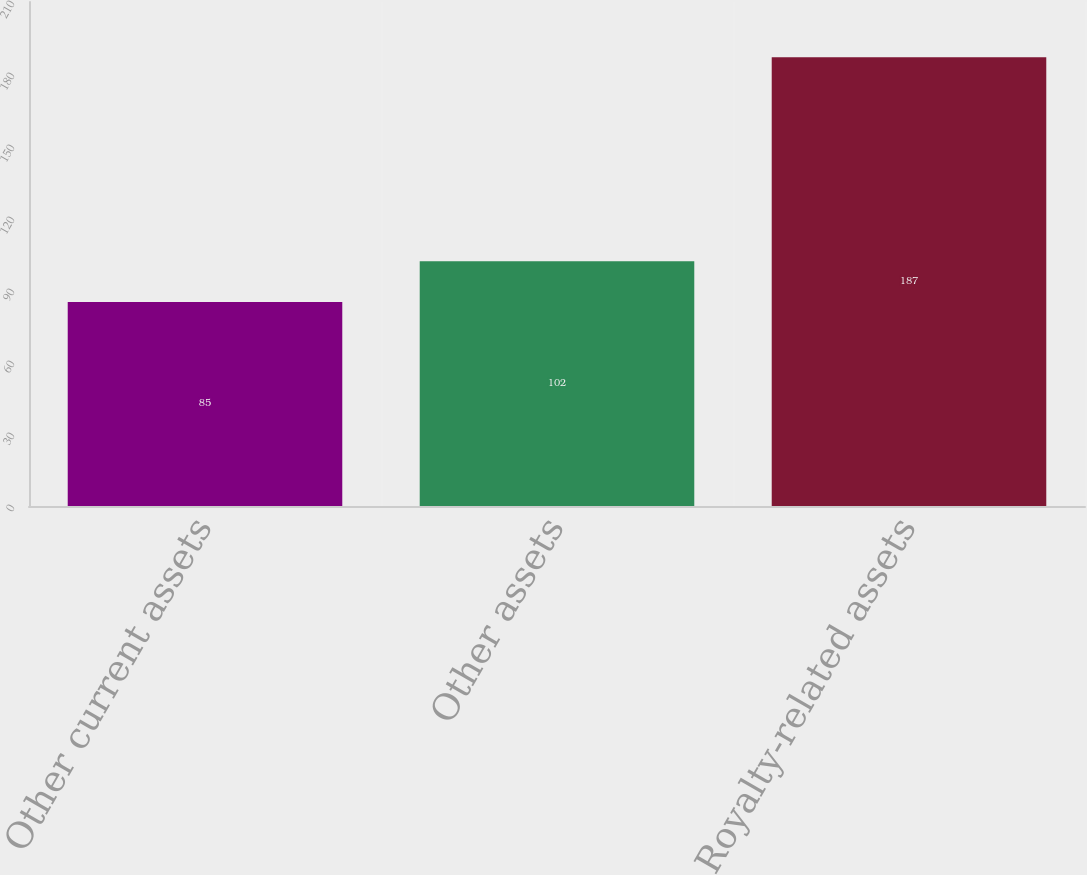<chart> <loc_0><loc_0><loc_500><loc_500><bar_chart><fcel>Other current assets<fcel>Other assets<fcel>Royalty-related assets<nl><fcel>85<fcel>102<fcel>187<nl></chart> 